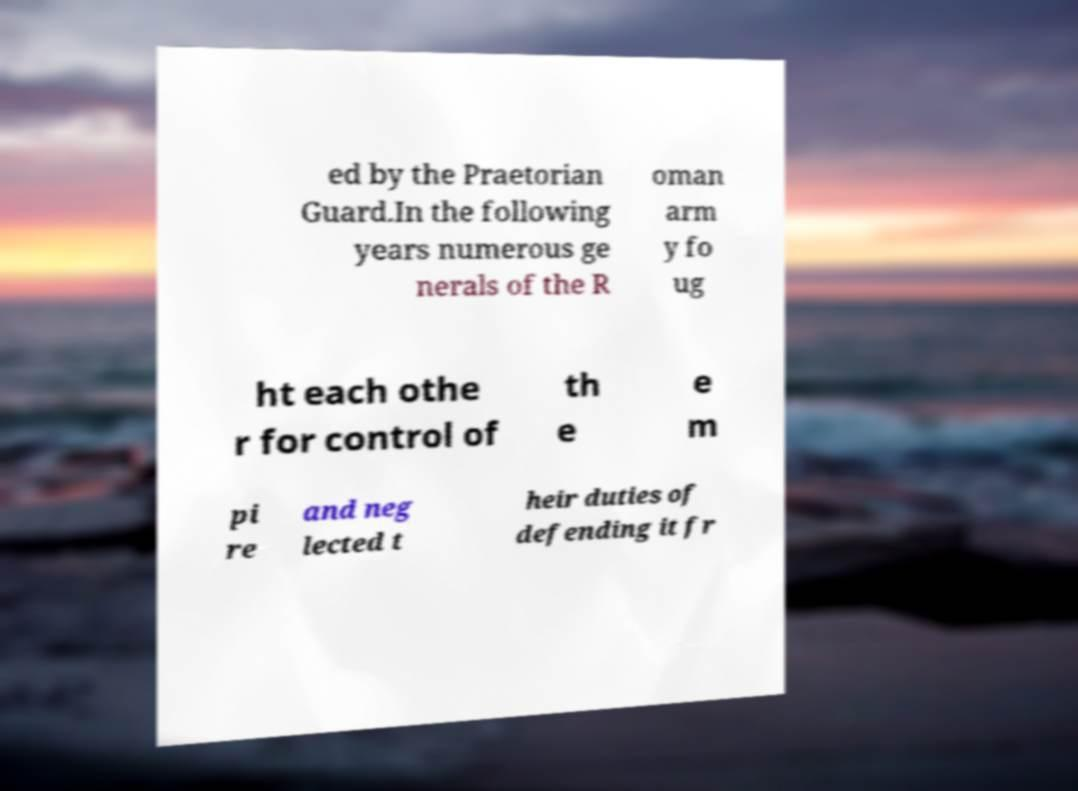I need the written content from this picture converted into text. Can you do that? ed by the Praetorian Guard.In the following years numerous ge nerals of the R oman arm y fo ug ht each othe r for control of th e e m pi re and neg lected t heir duties of defending it fr 